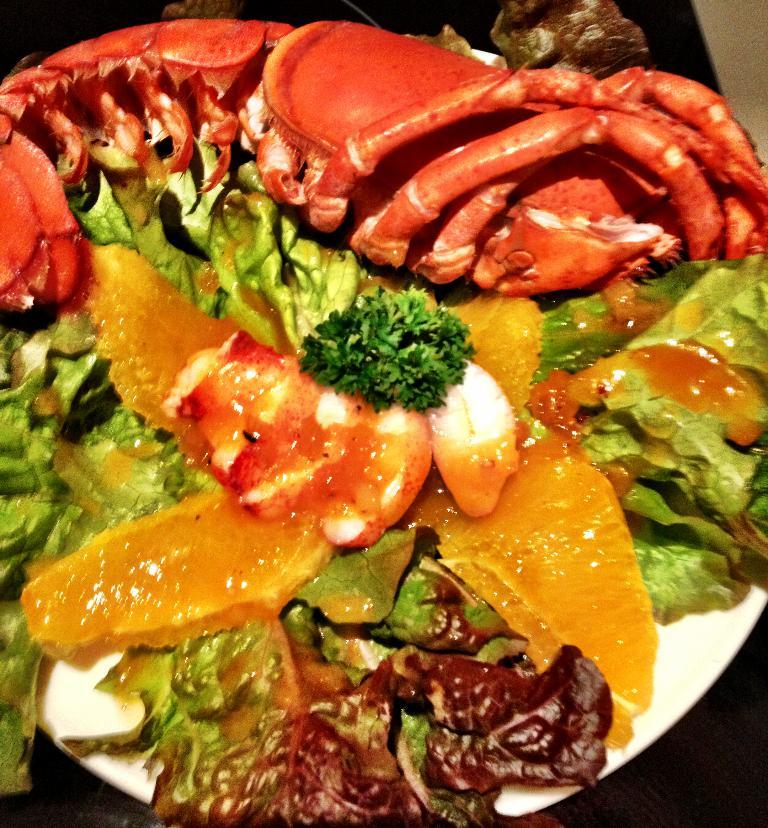What color is the plate in the image? The plate in the image is white colored. What is on the plate? The plate contains a food item. Can you describe the colors of the food item on the plate? The food item has brown, orange, red, white, and green colors. How does the grape on the plate affect the taste of the food item? There is no grape present on the plate in the image, so it cannot affect the taste of the food item. 